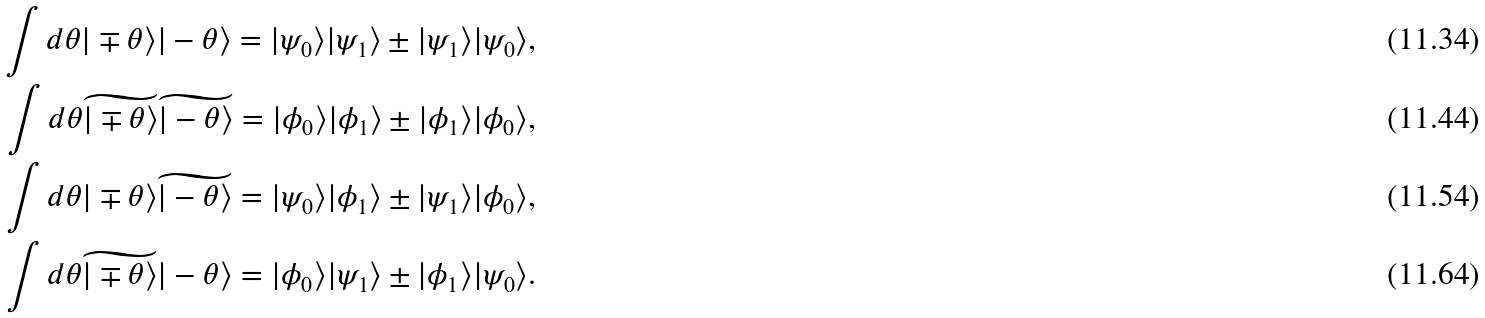<formula> <loc_0><loc_0><loc_500><loc_500>\int d \theta | \mp \theta \rangle | - \theta \rangle = | \psi _ { 0 } \rangle | \psi _ { 1 } \rangle \pm | \psi _ { 1 } \rangle | \psi _ { 0 } \rangle , \\ \int d \theta \widetilde { | \mp \theta \rangle } \widetilde { | - \theta \rangle } = | \phi _ { 0 } \rangle | \phi _ { 1 } \rangle \pm | \phi _ { 1 } \rangle | \phi _ { 0 } \rangle , \\ \int d \theta { | \mp \theta \rangle } \widetilde { | - \theta \rangle } = | \psi _ { 0 } \rangle | \phi _ { 1 } \rangle \pm | \psi _ { 1 } \rangle | \phi _ { 0 } \rangle , \\ \int d \theta \widetilde { | \mp \theta \rangle } { | - \theta \rangle } = | \phi _ { 0 } \rangle | \psi _ { 1 } \rangle \pm | \phi _ { 1 } \rangle | \psi _ { 0 } \rangle .</formula> 